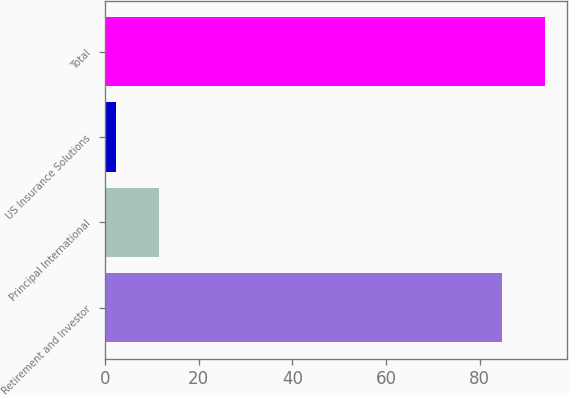Convert chart to OTSL. <chart><loc_0><loc_0><loc_500><loc_500><bar_chart><fcel>Retirement and Investor<fcel>Principal International<fcel>US Insurance Solutions<fcel>Total<nl><fcel>84.8<fcel>11.51<fcel>2.5<fcel>93.81<nl></chart> 